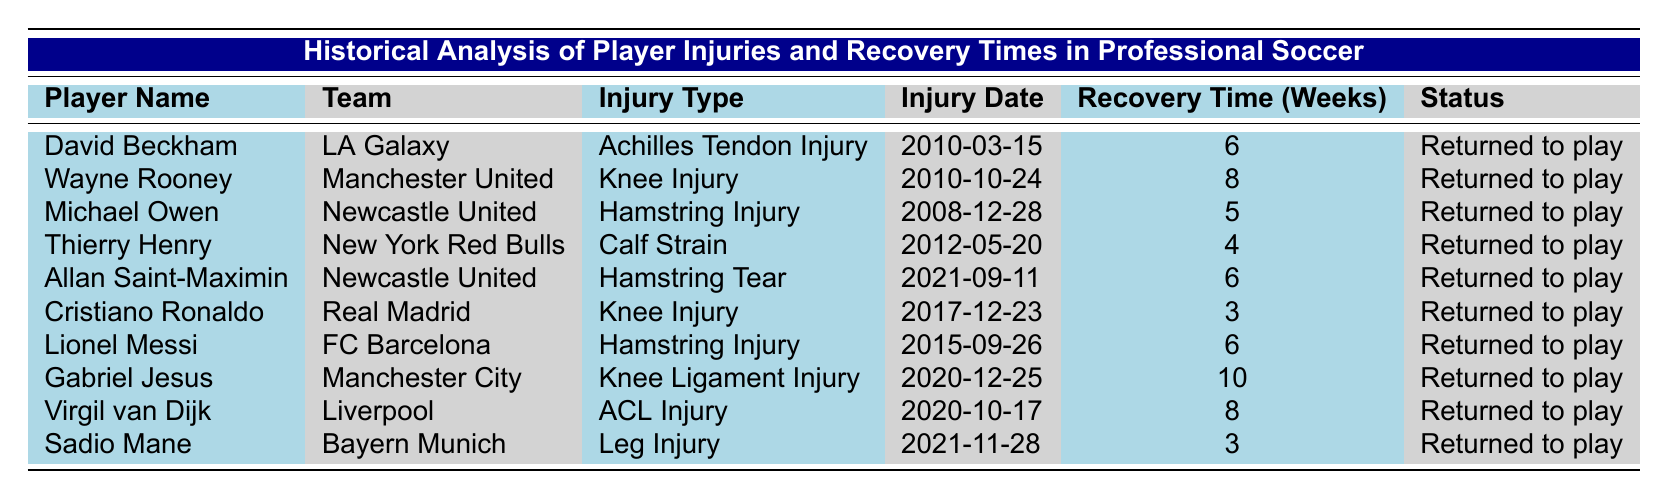What is the longest recovery time recorded in the table? The table lists recovery times, with Gabriel Jesus having the longest recovery time of 10 weeks, which is the highest value present.
Answer: 10 weeks How many players returned to play after suffering a hamstring injury? There are three players with hamstring injuries: Michael Owen, Allan Saint-Maximin, and Lionel Messi; all of them have a status of returned to play.
Answer: 3 players Did Cristiano Ronaldo sustain an injury in 2017? According to the table, Cristiano Ronaldo's injury date is listed as December 23, 2017, confirming that he did sustain an injury that year.
Answer: Yes Which team had a player with a calf strain and what was the recovery time? The player with a calf strain is Thierry Henry from the New York Red Bulls, and his recovery time was 4 weeks as per the table.
Answer: New York Red Bulls, 4 weeks What is the average recovery time for the injured players in the table? To find the average recovery time, sum the recovery times (6 + 8 + 5 + 4 + 6 + 3 + 6 + 10 + 8 + 3) = 57 weeks. There are 10 players, hence the average is 57/10 = 5.7 weeks.
Answer: 5.7 weeks Who are the players that returned to play after a knee injury? The players who returned to play after a knee injury are Wayne Rooney and Cristiano Ronaldo, as they both had knee injuries listed in the table.
Answer: Wayne Rooney, Cristiano Ronaldo Which player's recovery time was shorter than a month? The table shows that Sadio Mane and Cristiano Ronaldo both had recovery times of 3 weeks, which is less than a month.
Answer: Sadio Mane, Cristiano Ronaldo Is it true that all players listed have returned to play? Every player in the table has the status marked as "Returned to play," making the statement true.
Answer: Yes What was the injury type suffered by Virgil van Dijk and what was his recovery time? Virgil van Dijk suffered an ACL Injury, and according to the table, his recovery time was 8 weeks.
Answer: ACL Injury, 8 weeks How many players sustained injuries in 2021? The table lists two players who sustained injuries in 2021: Allan Saint-Maximin and Sadio Mane, making the total count two.
Answer: 2 players Which team had the highest recovery time and how many weeks was it? The highest recovery time recorded is 10 weeks for Gabriel Jesus who played for Manchester City, making it the longest recovery time.
Answer: Manchester City, 10 weeks 